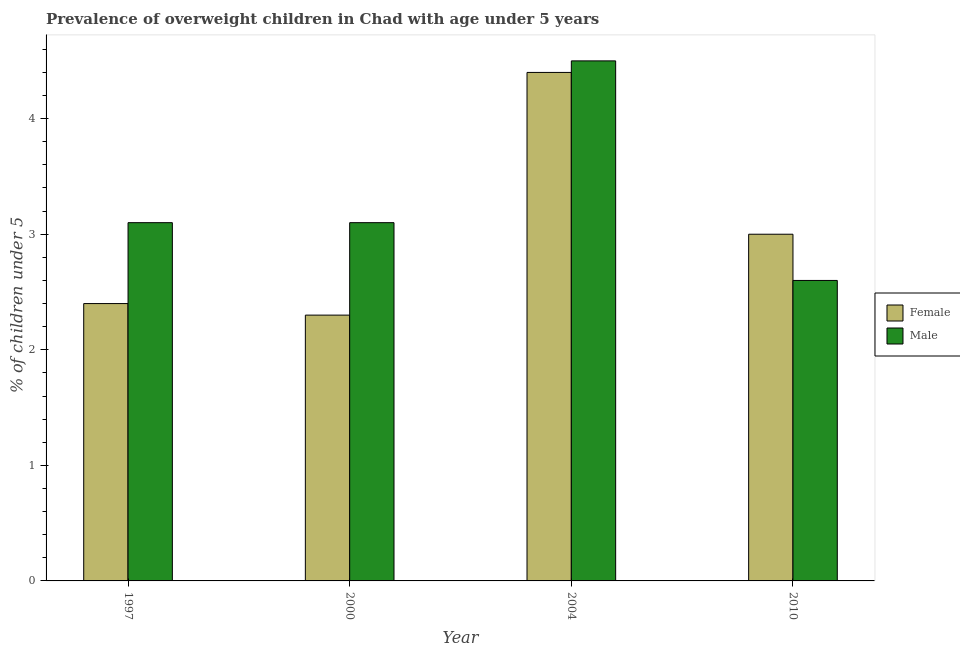How many different coloured bars are there?
Give a very brief answer. 2. How many groups of bars are there?
Offer a terse response. 4. How many bars are there on the 3rd tick from the right?
Give a very brief answer. 2. What is the label of the 4th group of bars from the left?
Keep it short and to the point. 2010. In how many cases, is the number of bars for a given year not equal to the number of legend labels?
Your answer should be very brief. 0. What is the percentage of obese male children in 1997?
Provide a short and direct response. 3.1. Across all years, what is the maximum percentage of obese female children?
Provide a short and direct response. 4.4. Across all years, what is the minimum percentage of obese female children?
Your response must be concise. 2.3. What is the total percentage of obese female children in the graph?
Your answer should be very brief. 12.1. What is the difference between the percentage of obese male children in 2000 and that in 2010?
Offer a very short reply. 0.5. What is the difference between the percentage of obese male children in 2010 and the percentage of obese female children in 2004?
Your answer should be compact. -1.9. What is the average percentage of obese male children per year?
Offer a very short reply. 3.32. In how many years, is the percentage of obese male children greater than 1.6 %?
Your answer should be compact. 4. What is the ratio of the percentage of obese male children in 1997 to that in 2004?
Your response must be concise. 0.69. Is the percentage of obese female children in 1997 less than that in 2010?
Offer a terse response. Yes. Is the difference between the percentage of obese male children in 1997 and 2000 greater than the difference between the percentage of obese female children in 1997 and 2000?
Ensure brevity in your answer.  No. What is the difference between the highest and the second highest percentage of obese female children?
Provide a short and direct response. 1.4. What is the difference between the highest and the lowest percentage of obese male children?
Provide a short and direct response. 1.9. In how many years, is the percentage of obese male children greater than the average percentage of obese male children taken over all years?
Keep it short and to the point. 1. Is the sum of the percentage of obese female children in 1997 and 2010 greater than the maximum percentage of obese male children across all years?
Make the answer very short. Yes. What does the 1st bar from the left in 2004 represents?
Your answer should be compact. Female. Are all the bars in the graph horizontal?
Give a very brief answer. No. Are the values on the major ticks of Y-axis written in scientific E-notation?
Keep it short and to the point. No. Does the graph contain any zero values?
Your answer should be compact. No. Does the graph contain grids?
Make the answer very short. No. Where does the legend appear in the graph?
Offer a very short reply. Center right. How many legend labels are there?
Offer a very short reply. 2. What is the title of the graph?
Provide a succinct answer. Prevalence of overweight children in Chad with age under 5 years. What is the label or title of the X-axis?
Your response must be concise. Year. What is the label or title of the Y-axis?
Your answer should be compact.  % of children under 5. What is the  % of children under 5 of Female in 1997?
Provide a succinct answer. 2.4. What is the  % of children under 5 of Male in 1997?
Offer a terse response. 3.1. What is the  % of children under 5 in Female in 2000?
Your response must be concise. 2.3. What is the  % of children under 5 in Male in 2000?
Offer a terse response. 3.1. What is the  % of children under 5 of Female in 2004?
Your response must be concise. 4.4. What is the  % of children under 5 of Female in 2010?
Give a very brief answer. 3. What is the  % of children under 5 in Male in 2010?
Your answer should be very brief. 2.6. Across all years, what is the maximum  % of children under 5 of Female?
Your response must be concise. 4.4. Across all years, what is the minimum  % of children under 5 in Female?
Offer a very short reply. 2.3. Across all years, what is the minimum  % of children under 5 in Male?
Give a very brief answer. 2.6. What is the total  % of children under 5 in Female in the graph?
Make the answer very short. 12.1. What is the difference between the  % of children under 5 in Male in 1997 and that in 2000?
Offer a terse response. 0. What is the difference between the  % of children under 5 of Female in 1997 and that in 2004?
Offer a very short reply. -2. What is the difference between the  % of children under 5 in Male in 1997 and that in 2004?
Provide a short and direct response. -1.4. What is the difference between the  % of children under 5 of Female in 1997 and that in 2010?
Provide a succinct answer. -0.6. What is the difference between the  % of children under 5 of Male in 1997 and that in 2010?
Make the answer very short. 0.5. What is the difference between the  % of children under 5 of Female in 2000 and that in 2004?
Give a very brief answer. -2.1. What is the difference between the  % of children under 5 of Male in 2000 and that in 2004?
Ensure brevity in your answer.  -1.4. What is the difference between the  % of children under 5 of Male in 2000 and that in 2010?
Make the answer very short. 0.5. What is the difference between the  % of children under 5 in Female in 2004 and that in 2010?
Offer a terse response. 1.4. What is the difference between the  % of children under 5 of Male in 2004 and that in 2010?
Keep it short and to the point. 1.9. What is the difference between the  % of children under 5 of Female in 1997 and the  % of children under 5 of Male in 2010?
Your response must be concise. -0.2. What is the difference between the  % of children under 5 of Female in 2000 and the  % of children under 5 of Male in 2010?
Your answer should be very brief. -0.3. What is the difference between the  % of children under 5 of Female in 2004 and the  % of children under 5 of Male in 2010?
Your answer should be compact. 1.8. What is the average  % of children under 5 in Female per year?
Keep it short and to the point. 3.02. What is the average  % of children under 5 of Male per year?
Your response must be concise. 3.33. In the year 2000, what is the difference between the  % of children under 5 of Female and  % of children under 5 of Male?
Provide a short and direct response. -0.8. In the year 2004, what is the difference between the  % of children under 5 in Female and  % of children under 5 in Male?
Offer a very short reply. -0.1. In the year 2010, what is the difference between the  % of children under 5 in Female and  % of children under 5 in Male?
Give a very brief answer. 0.4. What is the ratio of the  % of children under 5 in Female in 1997 to that in 2000?
Your answer should be compact. 1.04. What is the ratio of the  % of children under 5 in Female in 1997 to that in 2004?
Make the answer very short. 0.55. What is the ratio of the  % of children under 5 in Male in 1997 to that in 2004?
Give a very brief answer. 0.69. What is the ratio of the  % of children under 5 in Female in 1997 to that in 2010?
Provide a succinct answer. 0.8. What is the ratio of the  % of children under 5 in Male in 1997 to that in 2010?
Keep it short and to the point. 1.19. What is the ratio of the  % of children under 5 of Female in 2000 to that in 2004?
Give a very brief answer. 0.52. What is the ratio of the  % of children under 5 in Male in 2000 to that in 2004?
Your answer should be very brief. 0.69. What is the ratio of the  % of children under 5 in Female in 2000 to that in 2010?
Your answer should be compact. 0.77. What is the ratio of the  % of children under 5 of Male in 2000 to that in 2010?
Provide a short and direct response. 1.19. What is the ratio of the  % of children under 5 in Female in 2004 to that in 2010?
Your response must be concise. 1.47. What is the ratio of the  % of children under 5 of Male in 2004 to that in 2010?
Make the answer very short. 1.73. What is the difference between the highest and the second highest  % of children under 5 of Male?
Provide a succinct answer. 1.4. What is the difference between the highest and the lowest  % of children under 5 of Female?
Ensure brevity in your answer.  2.1. 